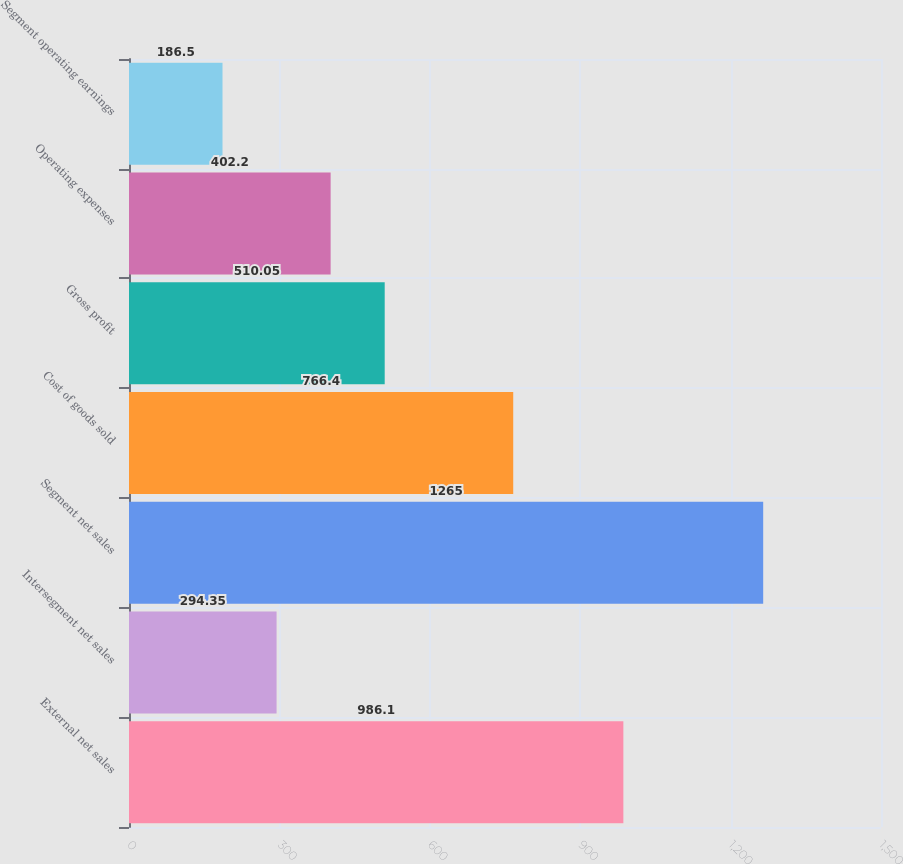Convert chart to OTSL. <chart><loc_0><loc_0><loc_500><loc_500><bar_chart><fcel>External net sales<fcel>Intersegment net sales<fcel>Segment net sales<fcel>Cost of goods sold<fcel>Gross profit<fcel>Operating expenses<fcel>Segment operating earnings<nl><fcel>986.1<fcel>294.35<fcel>1265<fcel>766.4<fcel>510.05<fcel>402.2<fcel>186.5<nl></chart> 